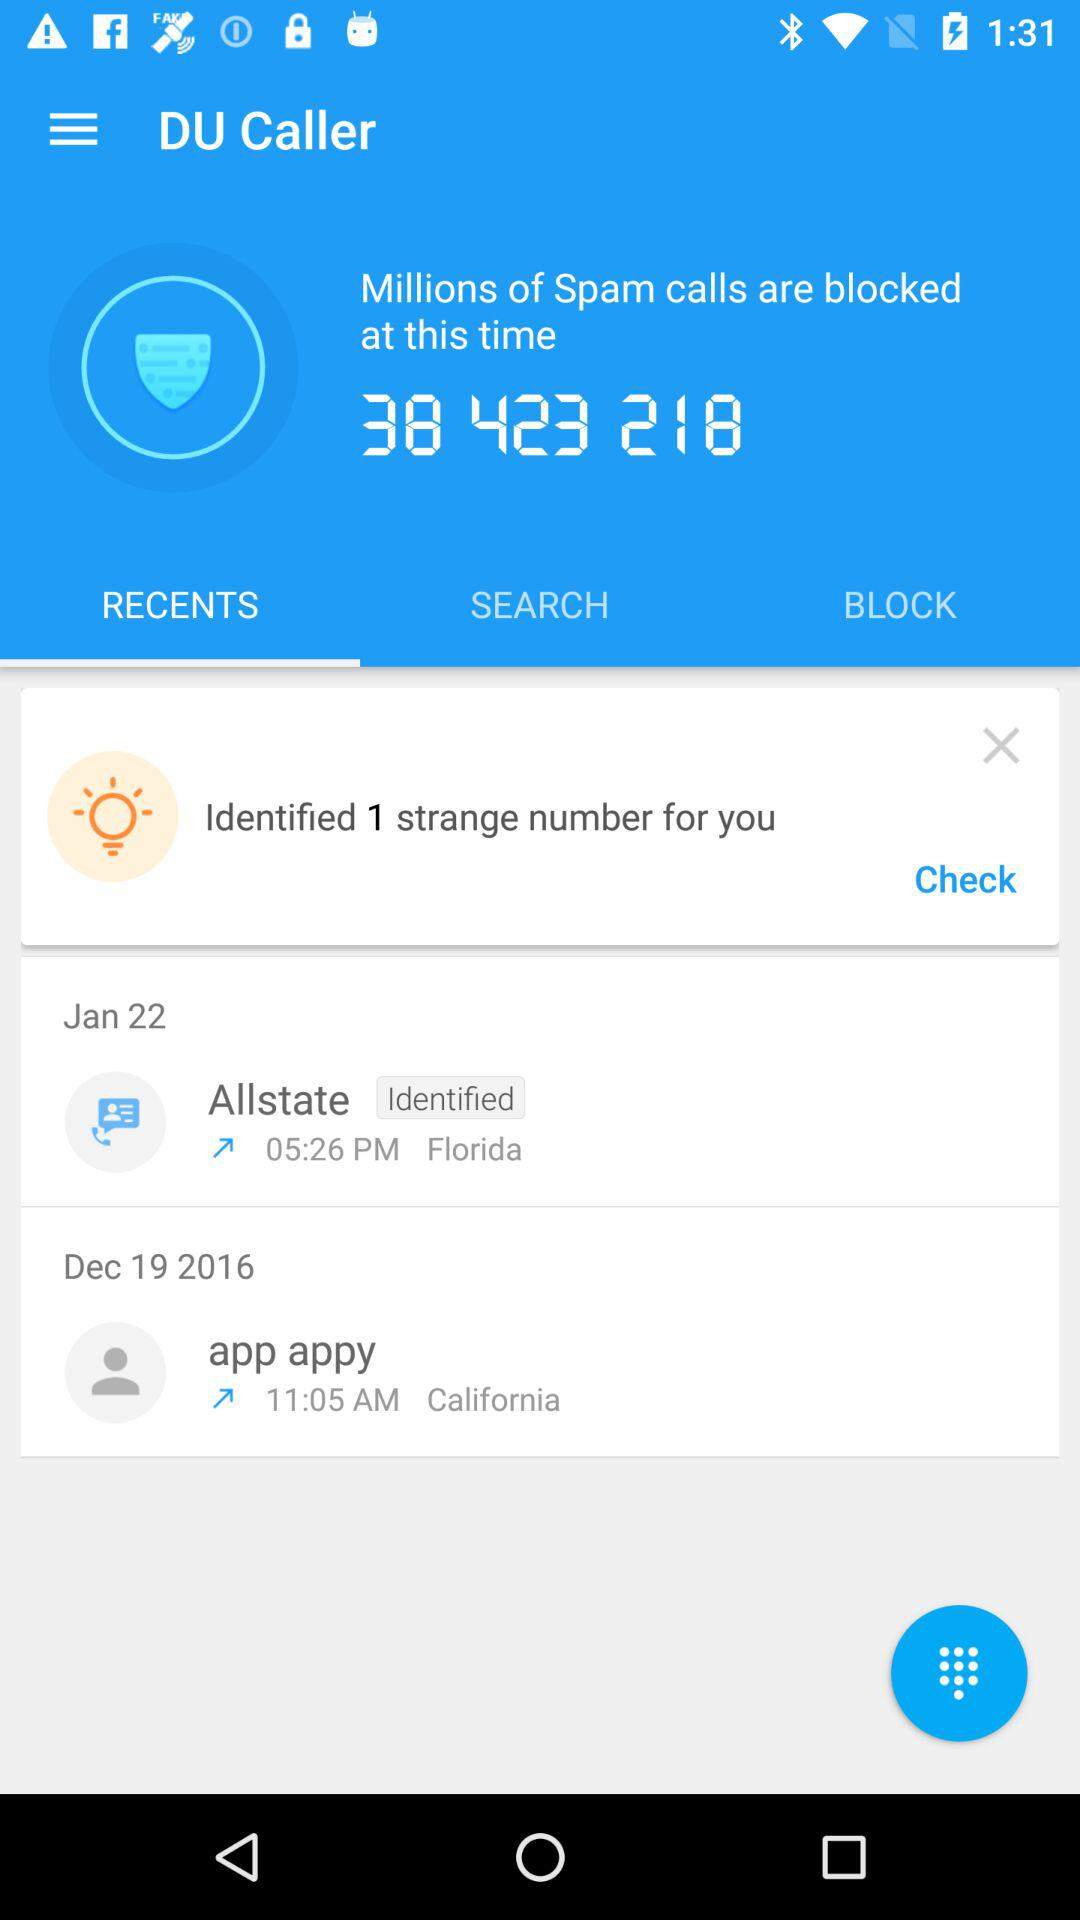What is the mentioned number for the blocked spam calls? The mentioned number for the blocked spam calls is 38,423,218. 